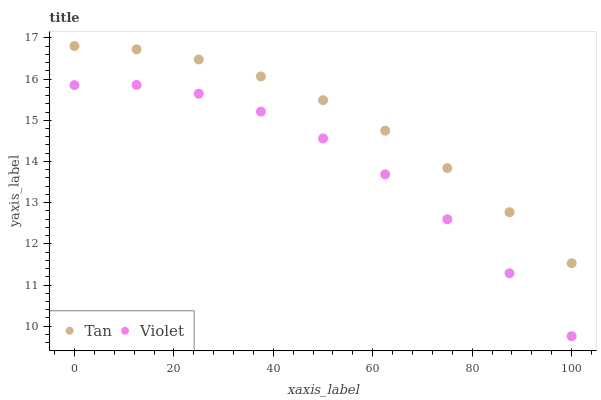Does Violet have the minimum area under the curve?
Answer yes or no. Yes. Does Tan have the maximum area under the curve?
Answer yes or no. Yes. Does Violet have the maximum area under the curve?
Answer yes or no. No. Is Tan the smoothest?
Answer yes or no. Yes. Is Violet the roughest?
Answer yes or no. Yes. Is Violet the smoothest?
Answer yes or no. No. Does Violet have the lowest value?
Answer yes or no. Yes. Does Tan have the highest value?
Answer yes or no. Yes. Does Violet have the highest value?
Answer yes or no. No. Is Violet less than Tan?
Answer yes or no. Yes. Is Tan greater than Violet?
Answer yes or no. Yes. Does Violet intersect Tan?
Answer yes or no. No. 